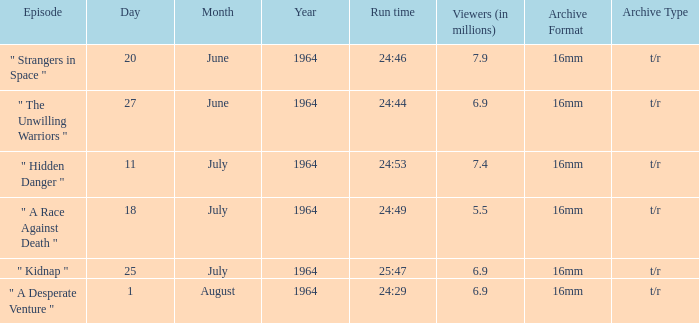What episode aired on 11july1964? " Hidden Danger ". 